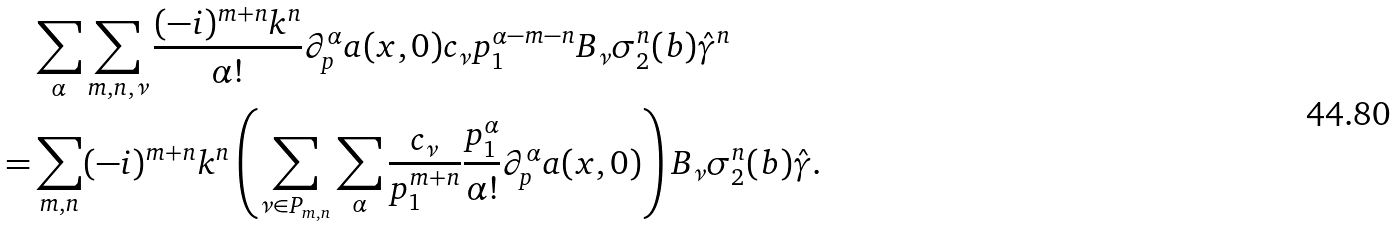Convert formula to latex. <formula><loc_0><loc_0><loc_500><loc_500>& \sum _ { \alpha } \sum _ { m , n , \nu } \frac { ( - i ) ^ { m + n } k ^ { n } } { \alpha ! } \partial _ { p } ^ { \alpha } a ( x , 0 ) c _ { \nu } p _ { 1 } ^ { \alpha - m - n } B _ { \nu } \sigma _ { 2 } ^ { n } ( b ) \hat { \gamma } ^ { n } \\ = & \sum _ { m , n } ( - i ) ^ { m + n } k ^ { n } \left ( \sum _ { \nu \in P _ { m , n } } \sum _ { \alpha } \frac { c _ { \nu } } { p _ { 1 } ^ { m + n } } \frac { p _ { 1 } ^ { \alpha } } { \alpha ! } \partial _ { p } ^ { \alpha } a ( x , 0 ) \right ) B _ { \nu } \sigma _ { 2 } ^ { n } ( b ) \hat { \gamma } .</formula> 